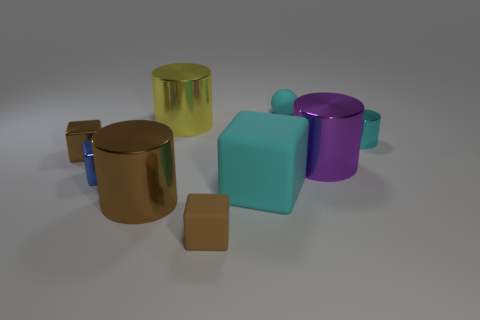Subtract all cylinders. How many objects are left? 5 Add 4 large shiny objects. How many large shiny objects are left? 7 Add 9 big blue rubber blocks. How many big blue rubber blocks exist? 9 Subtract 0 purple blocks. How many objects are left? 9 Subtract all small brown balls. Subtract all yellow shiny cylinders. How many objects are left? 8 